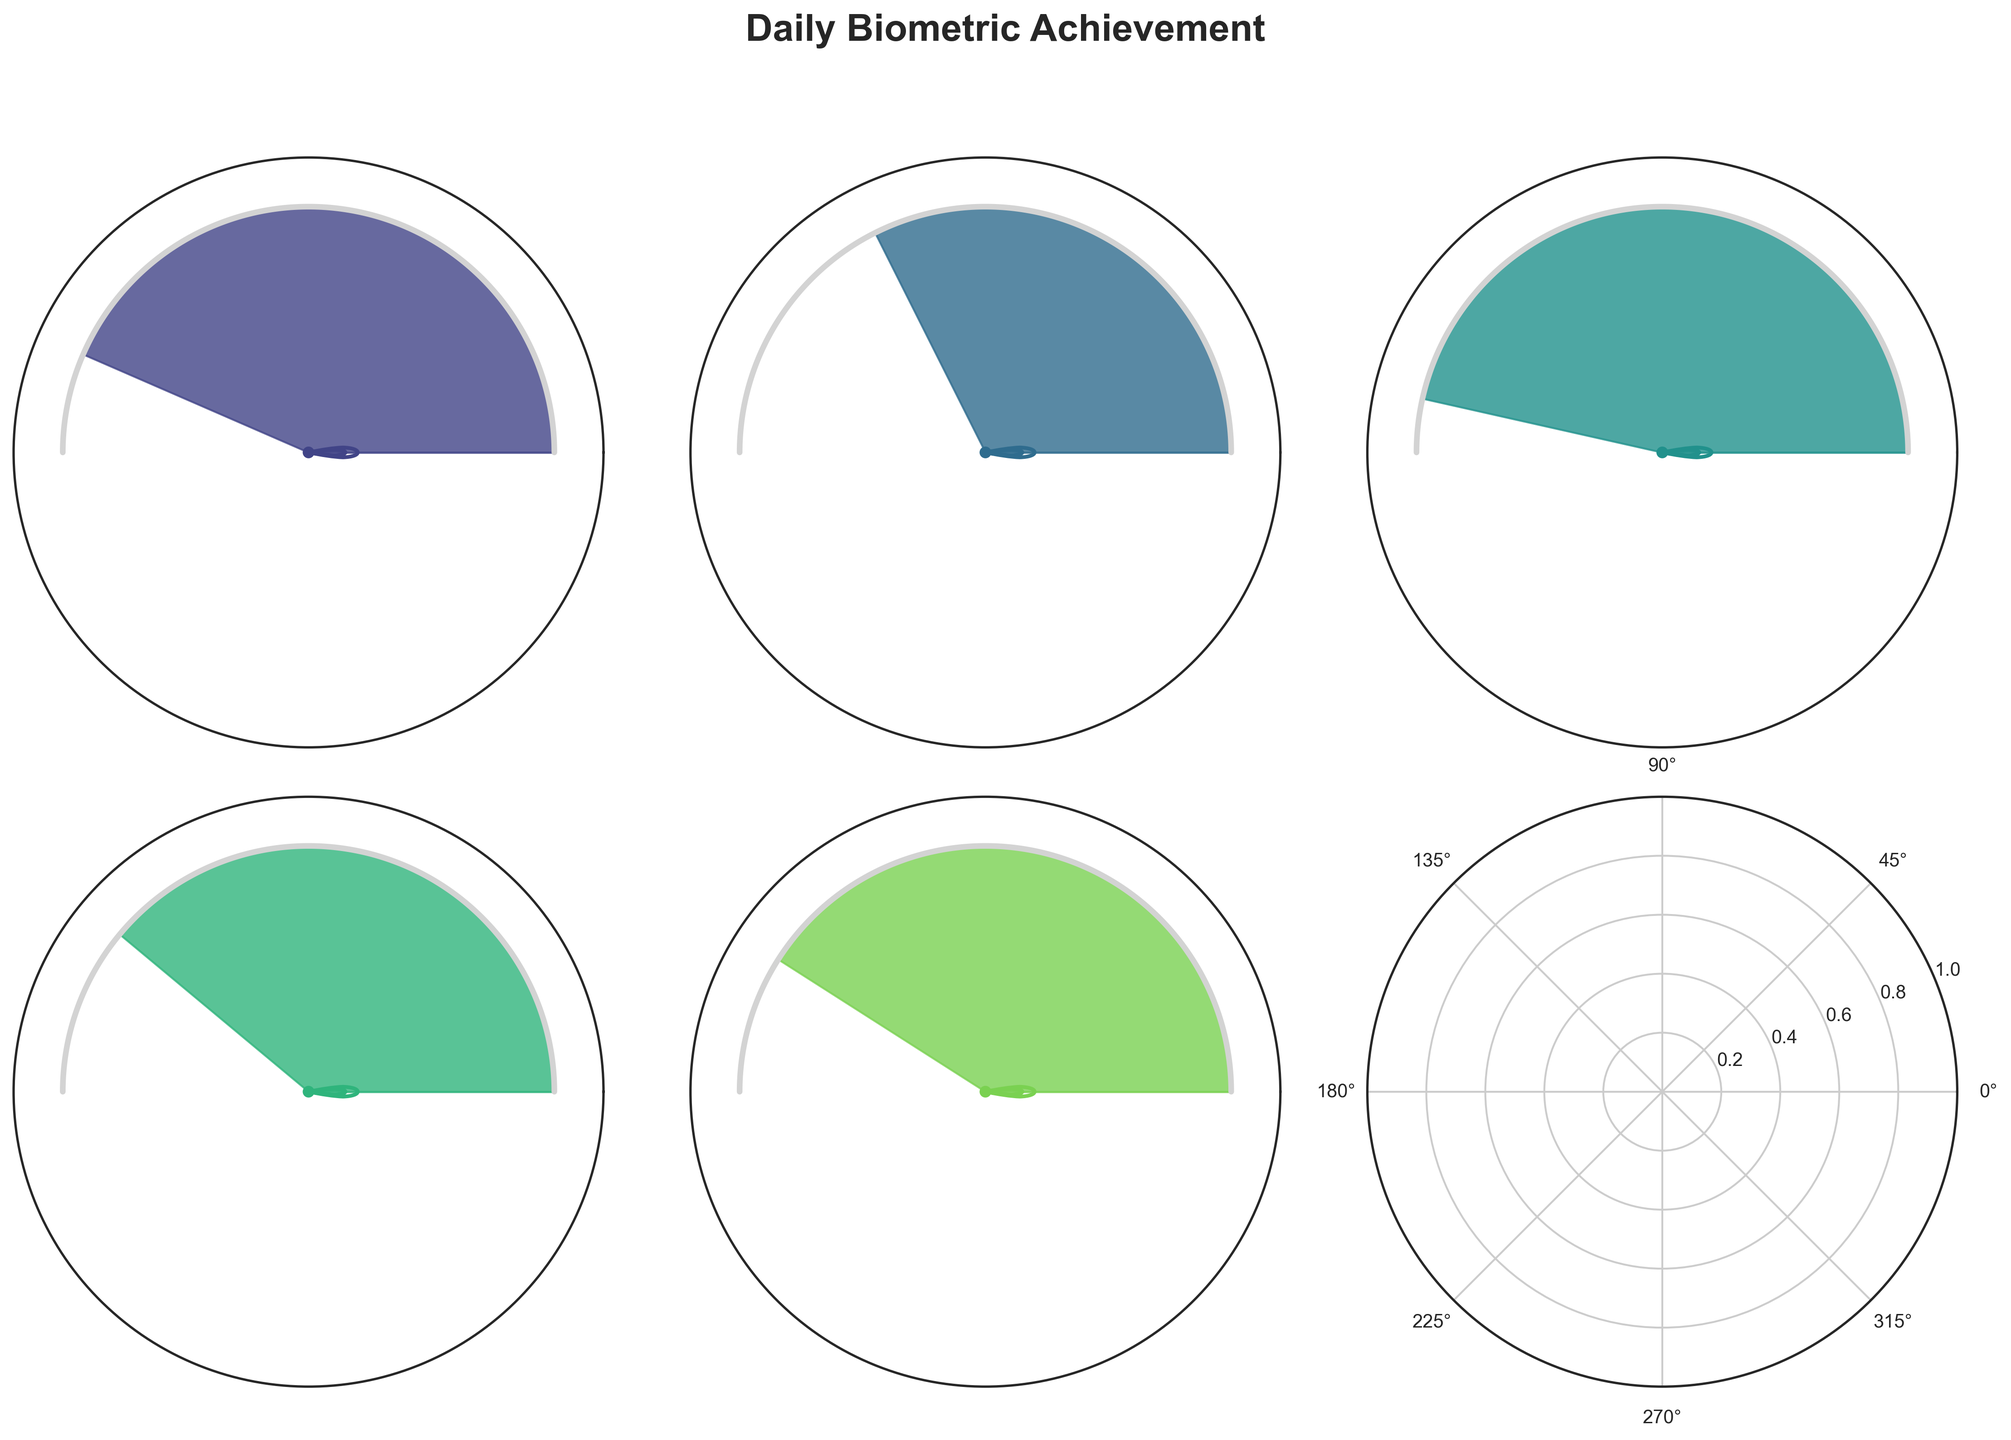What is the title of the figure? The title of the figure is displayed at the top center of the chart. It reads "Daily Biometric Achievement".
Answer: Daily Biometric Achievement How many subplots are in the figure? The figure contains a grid of subplots arranged in 2 rows and 3 columns. This means there are a total of 6 subplots, but only 5 have data.
Answer: 6 What is the achievement percentage for the Daily Step Goal? Locate the subplot titled "Daily Step Goal" and look at the percentage value displayed in the center of the gauge. The achievement percentage is 87%.
Answer: 87% Which goal has the highest achievement percentage? Compare the percentage values in the center of each gauge. The goal with the highest percentage is "Calories Burned" with 93%.
Answer: Calories Burned What is the average achievement percentage across all goals? Sum the percentages for all goals: 87 + 65 + 93 + 78 + 82 = 405. Divide by the number of goals: 405 / 5 = 81.
Answer: 81 Is the achievement percentage for Active Minutes less than that for Floors Climbed? Compare the percentages for Active Minutes (65%) and Floors Climbed (82%). Since 65 is less than 82, the answer is yes.
Answer: Yes Which goal has the lowest achievement percentage? Compare the percentage values in the center of each gauge. The goal with the lowest percentage is "Active Minutes" with 65%.
Answer: Active Minutes By how much does the achievement percentage for Distance Covered exceed that for Active Minutes? Subtract the Active Minutes percentage (65%) from the Distance Covered percentage (78%): 78 - 65 = 13.
Answer: 13 What is the color scheme used for the gauge charts? The gauge charts use a color scheme that ranges from light to dark green hues. This can be seen from the different shades used in the filled segments of the gauges.
Answer: Green hues Are there any subplots that don't contain any data? There is one subplot in the bottom right (2nd row, 3rd column) that has been removed because there is no corresponding data.
Answer: Yes 